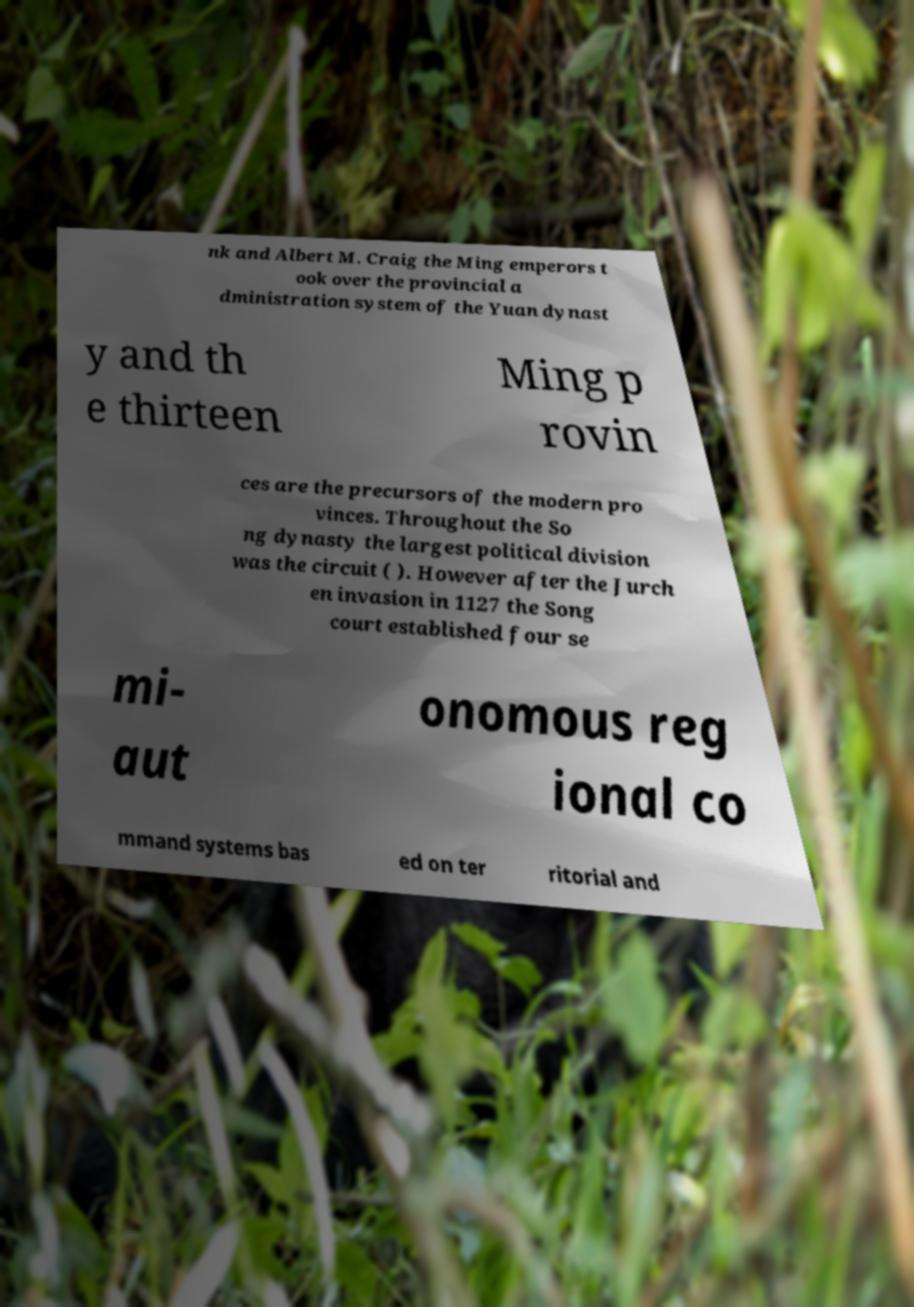Could you assist in decoding the text presented in this image and type it out clearly? nk and Albert M. Craig the Ming emperors t ook over the provincial a dministration system of the Yuan dynast y and th e thirteen Ming p rovin ces are the precursors of the modern pro vinces. Throughout the So ng dynasty the largest political division was the circuit ( ). However after the Jurch en invasion in 1127 the Song court established four se mi- aut onomous reg ional co mmand systems bas ed on ter ritorial and 